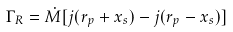<formula> <loc_0><loc_0><loc_500><loc_500>\Gamma _ { R } = \dot { M } [ j ( r _ { p } + x _ { s } ) - j ( r _ { p } - x _ { s } ) ]</formula> 